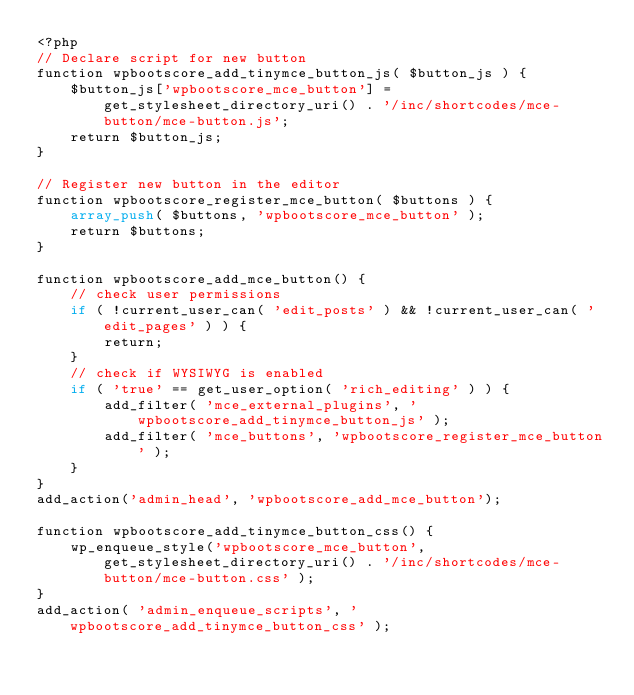<code> <loc_0><loc_0><loc_500><loc_500><_PHP_><?php
// Declare script for new button
function wpbootscore_add_tinymce_button_js( $button_js ) {
	$button_js['wpbootscore_mce_button'] = get_stylesheet_directory_uri() . '/inc/shortcodes/mce-button/mce-button.js';
	return $button_js;
}

// Register new button in the editor
function wpbootscore_register_mce_button( $buttons ) {
	array_push( $buttons, 'wpbootscore_mce_button' );
	return $buttons;
}

function wpbootscore_add_mce_button() {
	// check user permissions
	if ( !current_user_can( 'edit_posts' ) && !current_user_can( 'edit_pages' ) ) {
		return;
	}
	// check if WYSIWYG is enabled
	if ( 'true' == get_user_option( 'rich_editing' ) ) {
		add_filter( 'mce_external_plugins', 'wpbootscore_add_tinymce_button_js' );
		add_filter( 'mce_buttons', 'wpbootscore_register_mce_button' );
	}
}
add_action('admin_head', 'wpbootscore_add_mce_button');

function wpbootscore_add_tinymce_button_css() {
	wp_enqueue_style('wpbootscore_mce_button', get_stylesheet_directory_uri() . '/inc/shortcodes/mce-button/mce-button.css' );
}
add_action( 'admin_enqueue_scripts', 'wpbootscore_add_tinymce_button_css' );</code> 